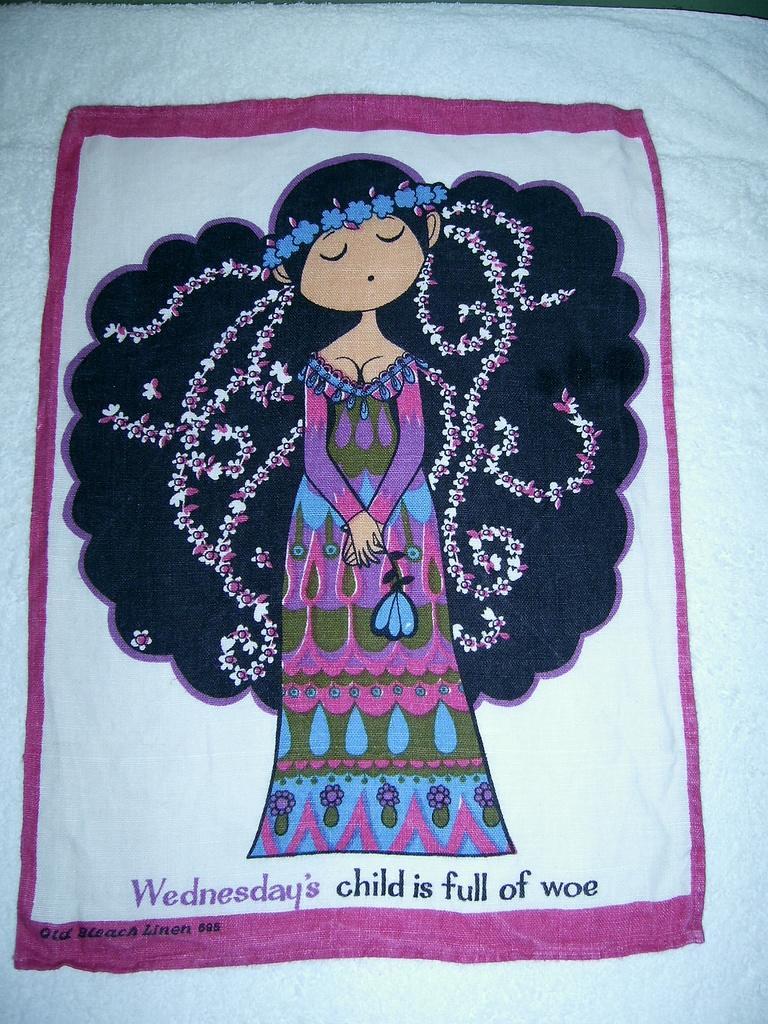Describe this image in one or two sentences. In this picture we can see a cloth. On the cloth there is a printed design of a doll and text. 